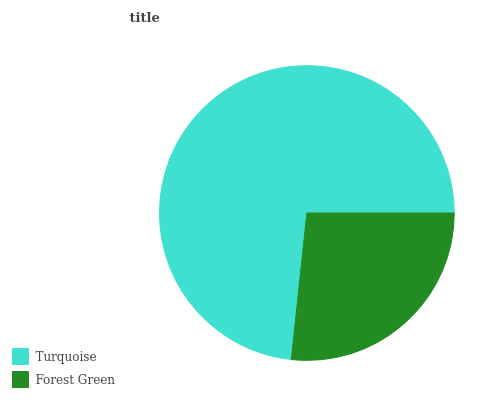Is Forest Green the minimum?
Answer yes or no. Yes. Is Turquoise the maximum?
Answer yes or no. Yes. Is Forest Green the maximum?
Answer yes or no. No. Is Turquoise greater than Forest Green?
Answer yes or no. Yes. Is Forest Green less than Turquoise?
Answer yes or no. Yes. Is Forest Green greater than Turquoise?
Answer yes or no. No. Is Turquoise less than Forest Green?
Answer yes or no. No. Is Turquoise the high median?
Answer yes or no. Yes. Is Forest Green the low median?
Answer yes or no. Yes. Is Forest Green the high median?
Answer yes or no. No. Is Turquoise the low median?
Answer yes or no. No. 